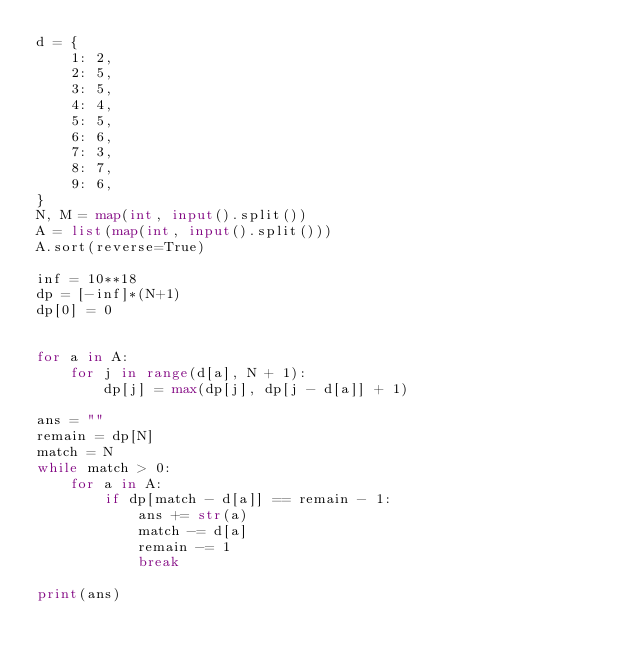Convert code to text. <code><loc_0><loc_0><loc_500><loc_500><_Python_>d = {
    1: 2,
    2: 5,
    3: 5,
    4: 4,
    5: 5,
    6: 6,
    7: 3,
    8: 7,
    9: 6,
}
N, M = map(int, input().split())
A = list(map(int, input().split()))
A.sort(reverse=True)

inf = 10**18
dp = [-inf]*(N+1)
dp[0] = 0


for a in A:
    for j in range(d[a], N + 1):
        dp[j] = max(dp[j], dp[j - d[a]] + 1)

ans = ""
remain = dp[N]
match = N
while match > 0:
    for a in A:
        if dp[match - d[a]] == remain - 1:
            ans += str(a)
            match -= d[a]
            remain -= 1
            break

print(ans)
</code> 